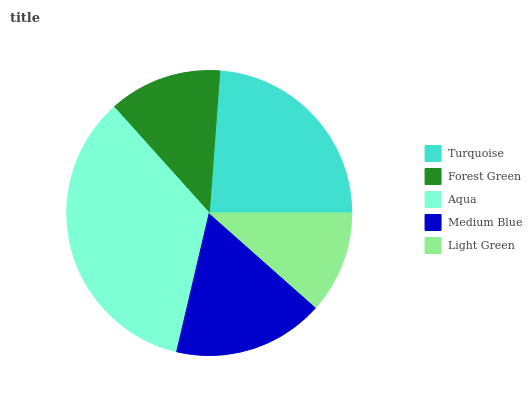Is Light Green the minimum?
Answer yes or no. Yes. Is Aqua the maximum?
Answer yes or no. Yes. Is Forest Green the minimum?
Answer yes or no. No. Is Forest Green the maximum?
Answer yes or no. No. Is Turquoise greater than Forest Green?
Answer yes or no. Yes. Is Forest Green less than Turquoise?
Answer yes or no. Yes. Is Forest Green greater than Turquoise?
Answer yes or no. No. Is Turquoise less than Forest Green?
Answer yes or no. No. Is Medium Blue the high median?
Answer yes or no. Yes. Is Medium Blue the low median?
Answer yes or no. Yes. Is Forest Green the high median?
Answer yes or no. No. Is Turquoise the low median?
Answer yes or no. No. 